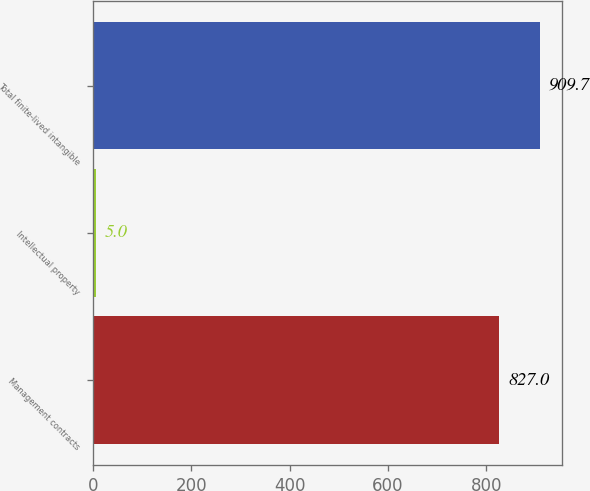Convert chart to OTSL. <chart><loc_0><loc_0><loc_500><loc_500><bar_chart><fcel>Management contracts<fcel>Intellectual property<fcel>Total finite-lived intangible<nl><fcel>827<fcel>5<fcel>909.7<nl></chart> 